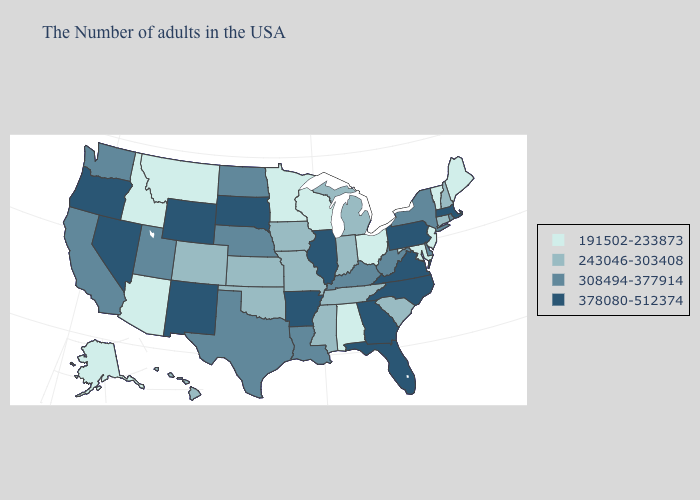Among the states that border New York , does Pennsylvania have the highest value?
Quick response, please. Yes. Among the states that border Pennsylvania , does New Jersey have the highest value?
Write a very short answer. No. Does Alaska have the highest value in the USA?
Short answer required. No. Does Georgia have the highest value in the South?
Be succinct. Yes. What is the value of Florida?
Give a very brief answer. 378080-512374. Does Massachusetts have the highest value in the USA?
Keep it brief. Yes. What is the value of Wisconsin?
Short answer required. 191502-233873. Does Ohio have the highest value in the USA?
Be succinct. No. What is the value of Missouri?
Quick response, please. 243046-303408. Does Arizona have a higher value than South Dakota?
Keep it brief. No. What is the value of Kentucky?
Keep it brief. 308494-377914. Among the states that border North Dakota , which have the highest value?
Short answer required. South Dakota. Name the states that have a value in the range 308494-377914?
Quick response, please. Rhode Island, New York, Delaware, West Virginia, Kentucky, Louisiana, Nebraska, Texas, North Dakota, Utah, California, Washington. Which states have the lowest value in the Northeast?
Keep it brief. Maine, Vermont, New Jersey. Name the states that have a value in the range 243046-303408?
Short answer required. New Hampshire, Connecticut, South Carolina, Michigan, Indiana, Tennessee, Mississippi, Missouri, Iowa, Kansas, Oklahoma, Colorado, Hawaii. 